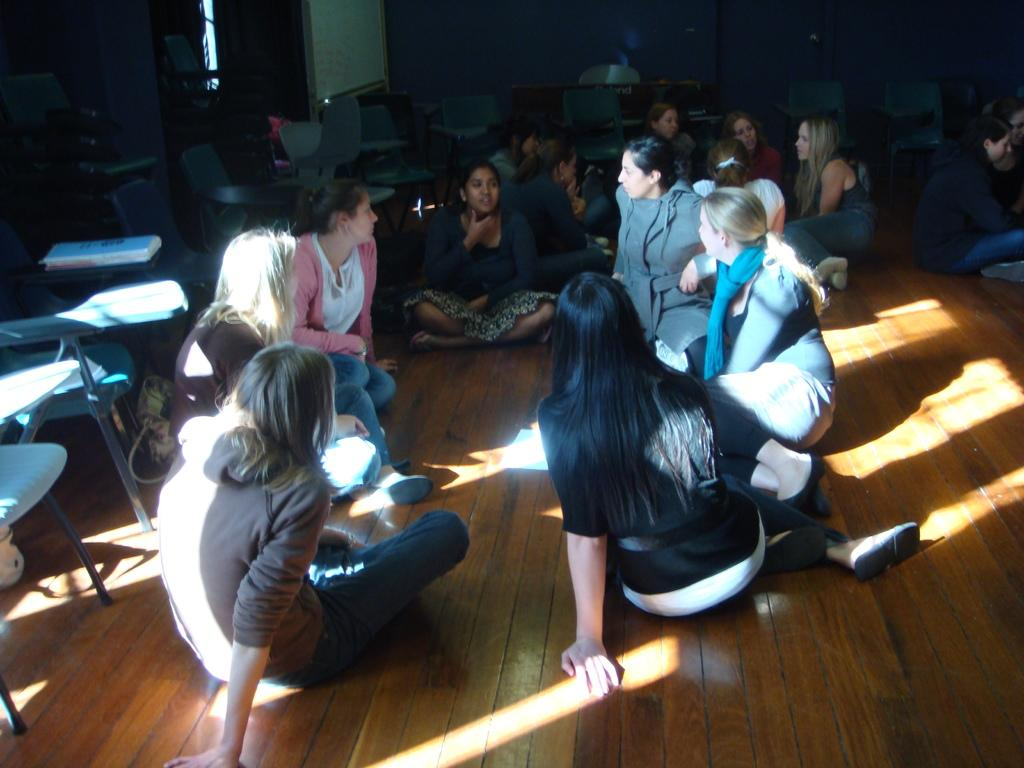What are the people in the image doing? The people in the image are seated on the floor. What type of furniture is visible in the image? There are chairs in the image. Can you describe the background of the image? There appears to be a table in the background of the image. What type of story is being told by the people seated on the floor in the image? There is no indication in the image that a story is being told, so it cannot be determined from the picture. 